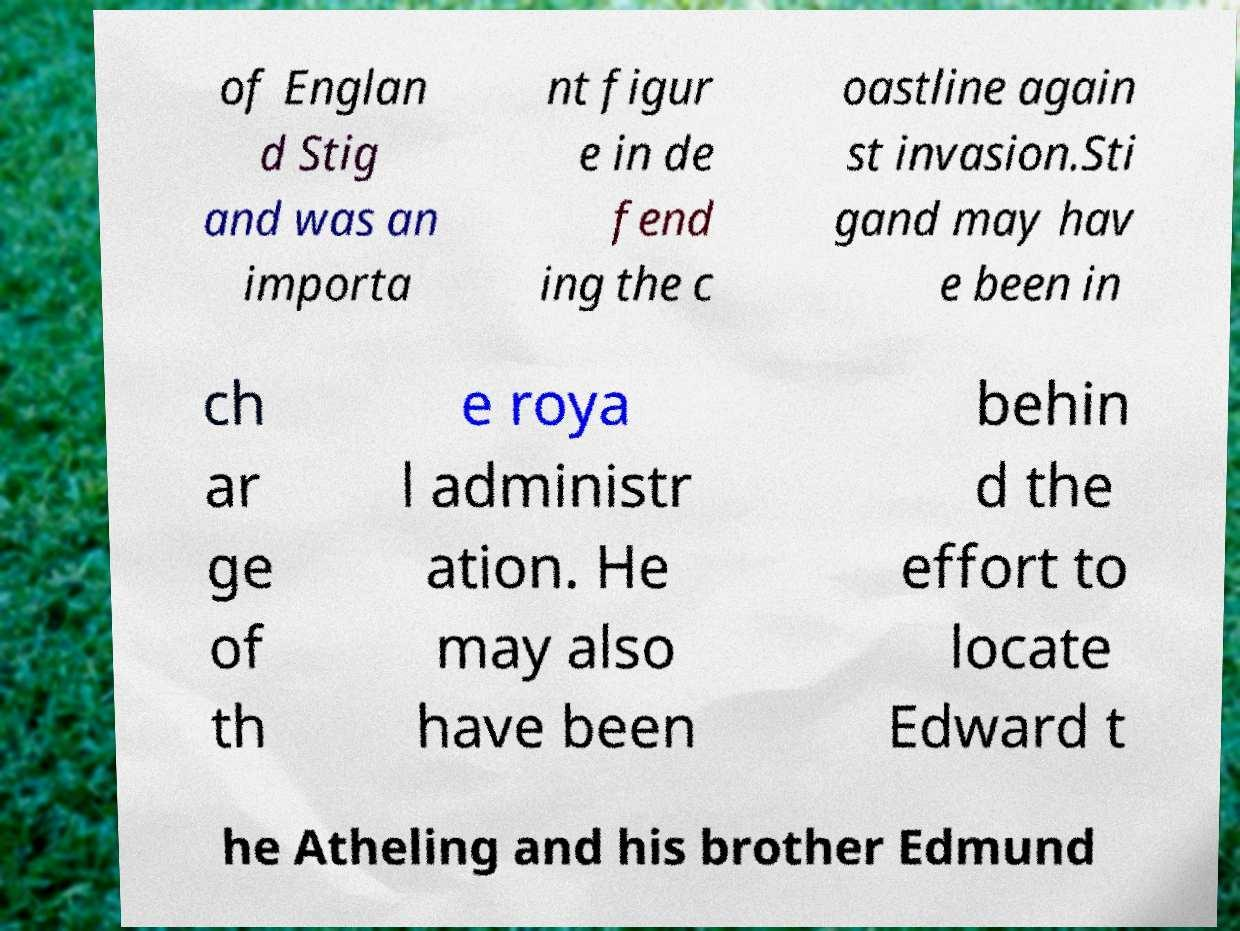There's text embedded in this image that I need extracted. Can you transcribe it verbatim? of Englan d Stig and was an importa nt figur e in de fend ing the c oastline again st invasion.Sti gand may hav e been in ch ar ge of th e roya l administr ation. He may also have been behin d the effort to locate Edward t he Atheling and his brother Edmund 